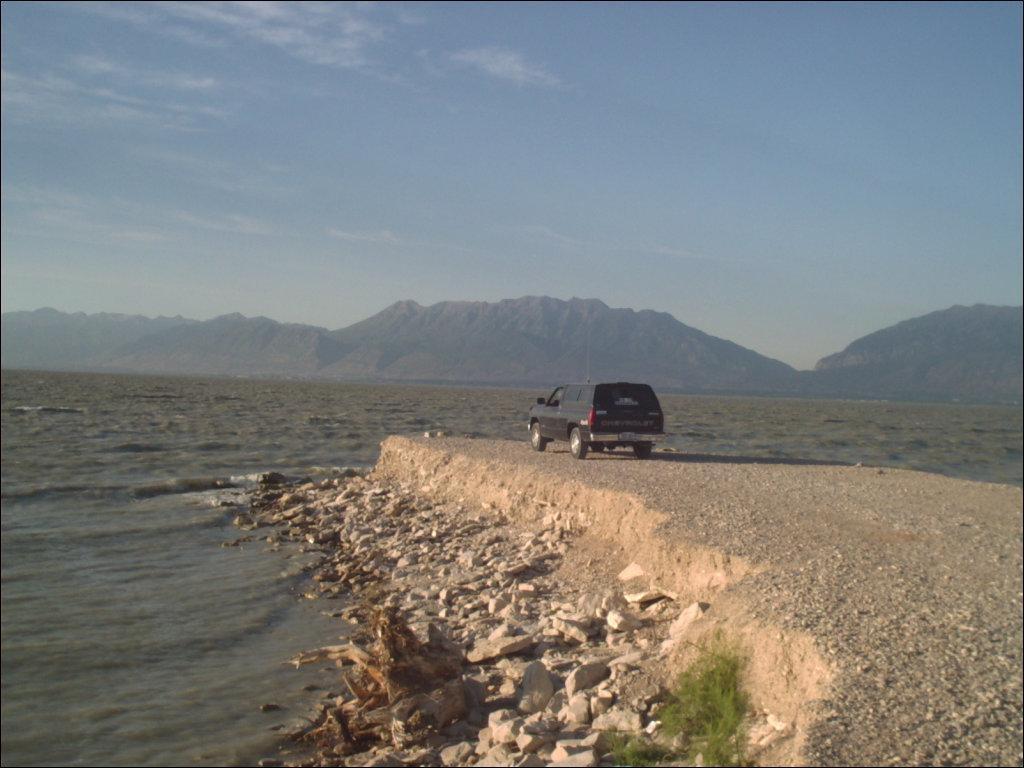Please provide a concise description of this image. In this image we can see a vehicle on the ground and there are some rocks and grass. We can see the water and in the background, we can see the mountains and at the top we can see the sky. 